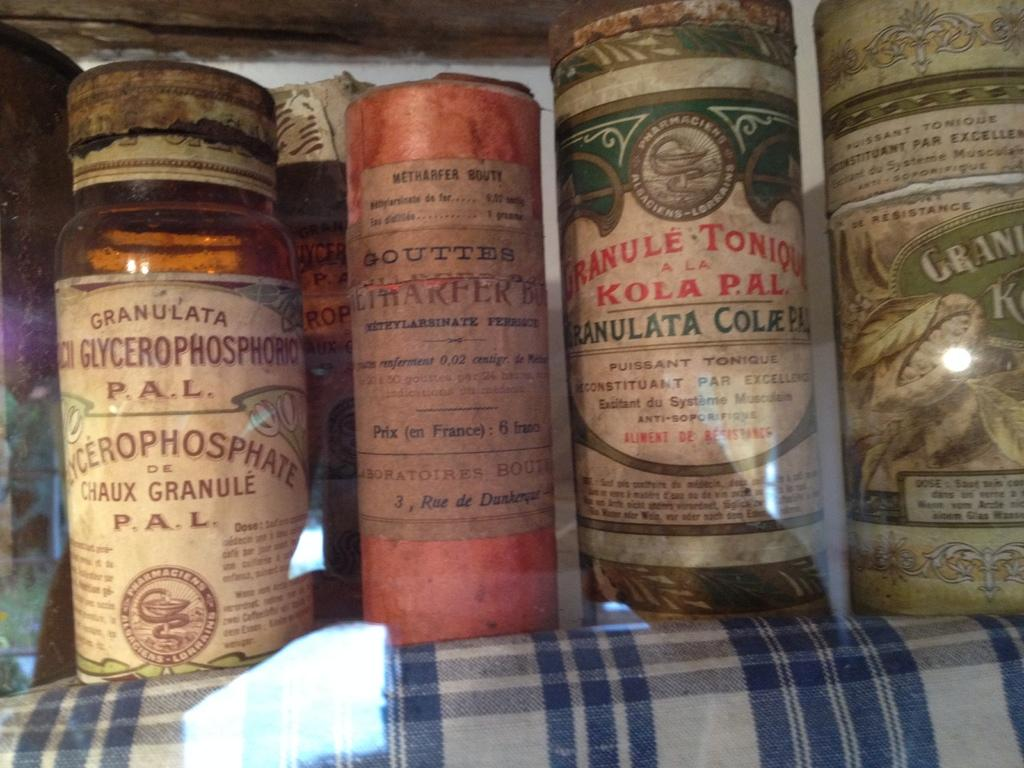<image>
Share a concise interpretation of the image provided. Four containers with really old labels on them and one says Granulata on the top of the label. 